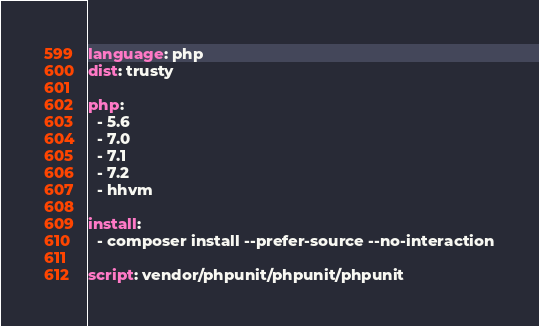<code> <loc_0><loc_0><loc_500><loc_500><_YAML_>language: php
dist: trusty

php:
  - 5.6
  - 7.0
  - 7.1
  - 7.2
  - hhvm

install:
  - composer install --prefer-source --no-interaction

script: vendor/phpunit/phpunit/phpunit</code> 